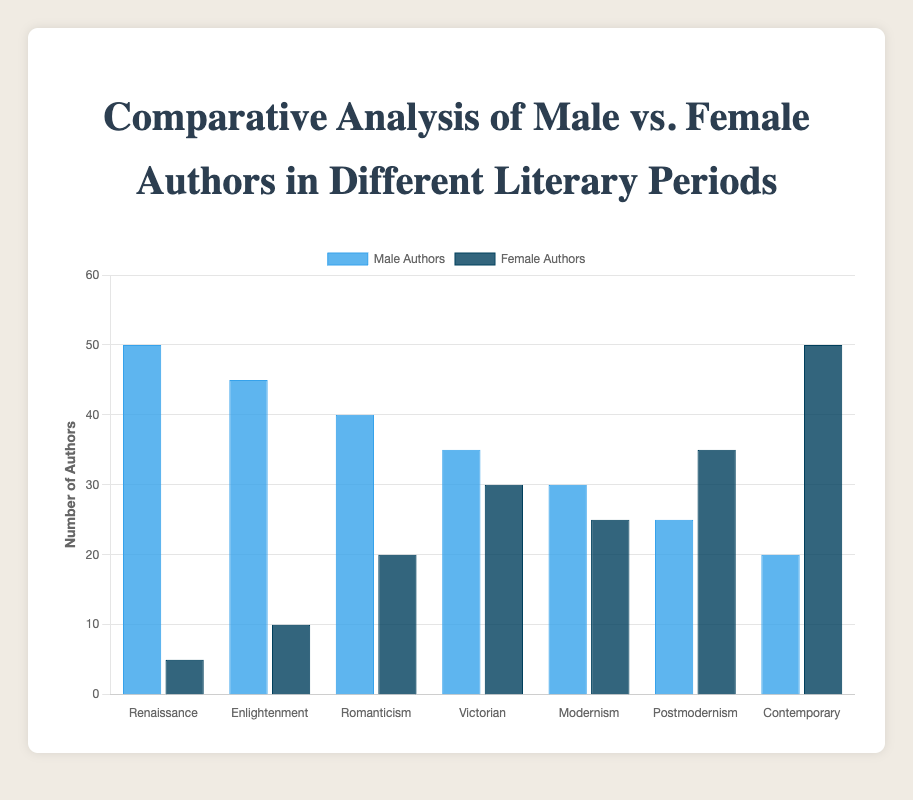What literary period has the highest number of male authors? To find the literary period with the highest number of male authors, we look at the blue bars representing male authors. The Renaissance period has the highest bar for male authors, indicating the highest number.
Answer: Renaissance Which period shows the highest representation of female authors? To identify the period with the highest number of female authors, we look at the dark blue bars representing female authors. The Contemporary period has the tallest bar for female authors, indicating the highest representation.
Answer: Contemporary In which period is the difference between male and female authors the largest? Calculate the difference between the number of male and female authors for each period. Renaissance: 50 - 5 = 45, Enlightenment: 45 - 10 = 35, Romanticism: 40 - 20 = 20, Victorian: 35 - 30 = 5, Modernism: 30 - 25 = 5, Postmodernism: 25 - 35 = -10, Contemporary: 20 - 50 = -30. The Renaissance period has the largest difference with 45.
Answer: Renaissance How does the number of male authors in the Romanticism period compare to the number of female authors in the same period? Look at the blue bar for male authors and the dark blue bar for female authors in the Romanticism period. Male authors: 40, Female authors: 20. 40 is greater than 20, so there are more male authors.
Answer: More male authors in Romanticism What's the average number of female authors in the Modernism and Postmodernism periods? Sum the numbers of female authors in the Modernism and Postmodernism periods: 25 + 35 = 60. Then, divide by 2 (number of periods): 60 / 2 = 30.
Answer: 30 Which period had an equal number of male and female authors? Compare the heights of the blue and dark blue bars for each period. None of the periods show an exact equal height between male and female authors.
Answer: None What was the visual trend in the number of female authors from Renaissance to Contemporary? Observe the dark blue bars from Renaissance to Contemporary. The bars increase in height, indicating an upward trend in the number of female authors over time.
Answer: Increasing trend During which periods did the number of female authors exceed the number of male authors? Identify the periods where the dark blue bar (female authors) is taller than the blue bar (male authors). Postmodernism (35 > 25) and Contemporary (50 > 20).
Answer: Postmodernism, Contemporary What's the total number of authors (male and female) in the Victorian period? Add the numbers of male and female authors in the Victorian period: 35 (male) + 30 (female) = 65.
Answer: 65 Compare the number of male authors in the Enlightenment period with the number of female authors in the Contemporary period. Male authors in the Enlightenment period: 45, Female authors in the Contemporary period: 50. 50 is greater than 45, so there are more female authors in the Contemporary period.
Answer: More female authors in Contemporary 